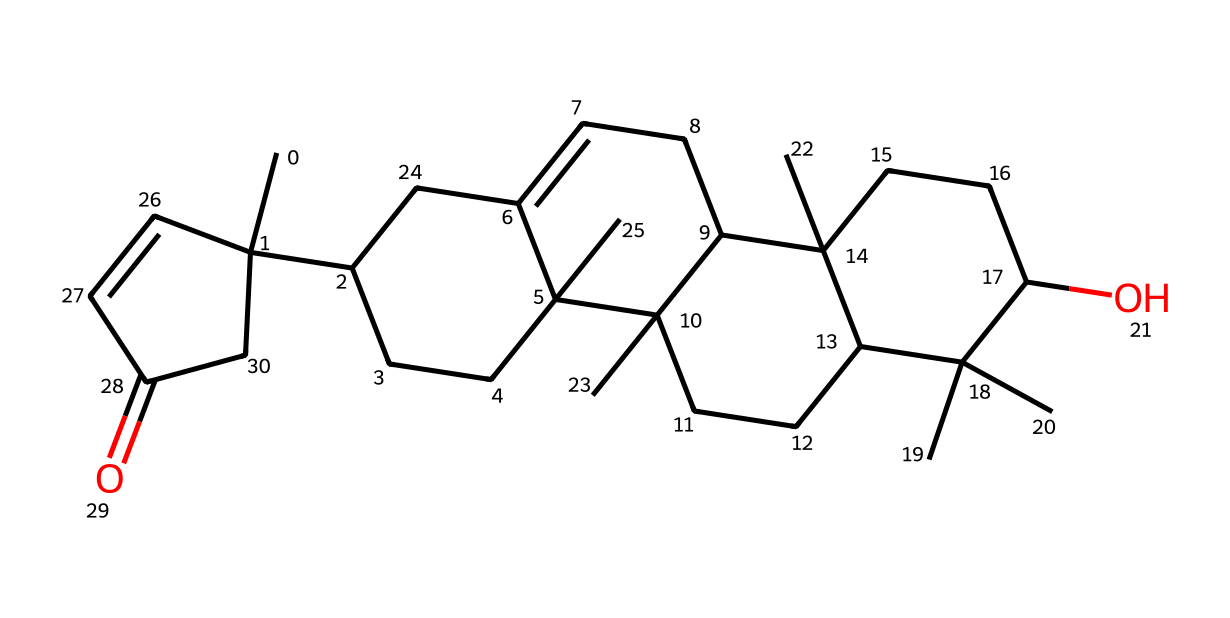What is the molecular formula of the compound represented by the SMILES? To find the molecular formula, count the number of each type of atom in the SMILES structure. Each 'C' represents a carbon atom and 'O' represents an oxygen atom. There are 30 carbon atoms and 1 oxygen atom. Therefore, the molecular formula is C30H50O.
Answer: C30H50O How many rings are present in the structure? A ring is identified in structural formulas where atoms are connected back to themselves. By examining the SMILES representation closely, there are three distinct cyclic structures present.
Answer: 3 What functional group is indicated in this molecule? The presence of 'C(=O)' in the SMILES indicates a carbonyl group (C=O), which is characteristic of ketones or aldehydes. In the context of frankincense, this points to a ketone functional group.
Answer: ketone What type of hydrocarbon is represented here? Given the presence of multiple carbon and hydrogen atoms, and noting the cyclic nature along with the functional group, this compound belongs to the class of terpenes, which are a type of hydrocarbons derived from plant sources.
Answer: terpene Identify one main use of frankincense in cultural practices. Frankincense is commonly used in incense during various religious ceremonies, particularly in Jewish rituals and traditions.
Answer: incense What characteristic aroma is associated with this compound? Frankincense is known for its distinct aromatic quality, often described as warm, spicy, and resinous. This aroma is linked to its use in spiritual and ceremonial contexts.
Answer: aromatic In terms of structural complexity, how does this compound compare to simpler hydrocarbons? The complexity arises from its multiple rings and the presence of functional groups, distinguishing it significantly from simpler hydrocarbons, which generally consist of straight or branched chains without rings or varied functional groups.
Answer: complex 